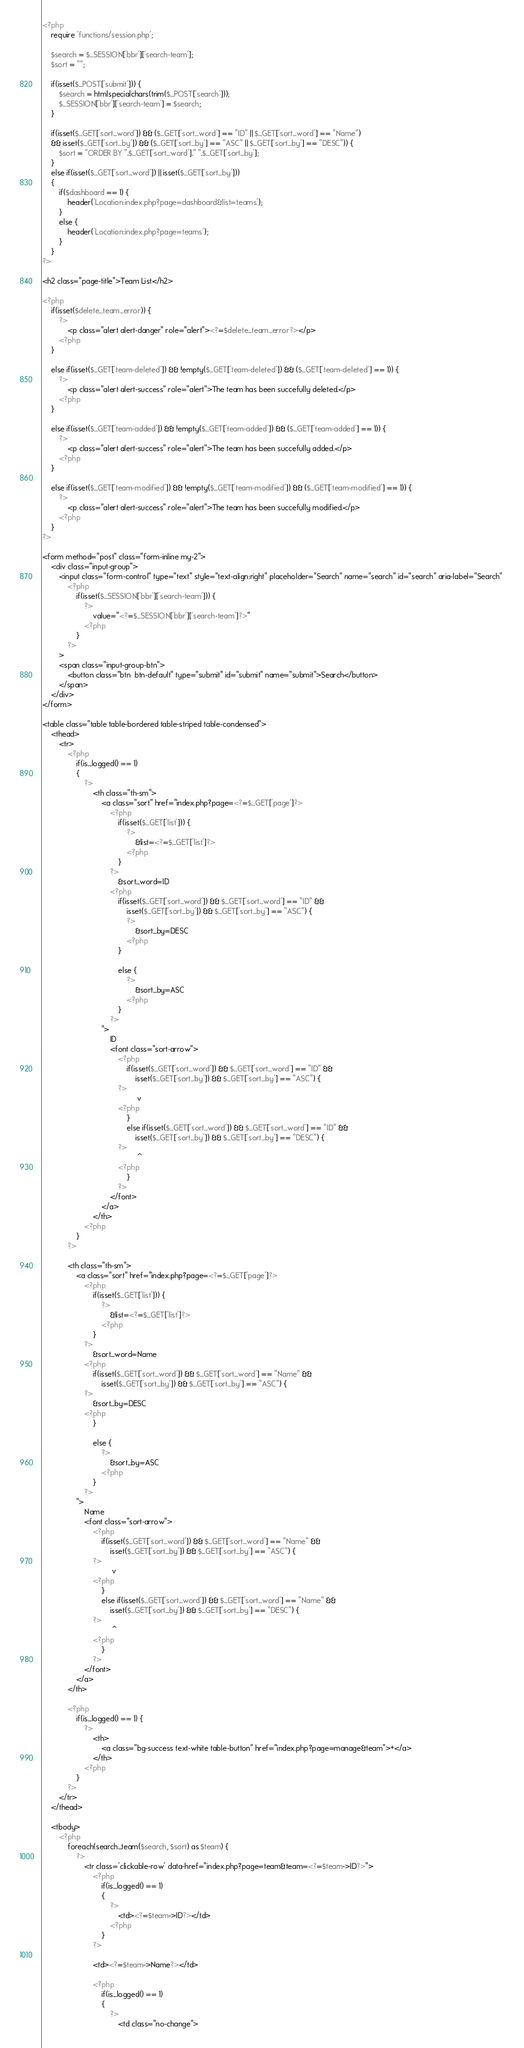Convert code to text. <code><loc_0><loc_0><loc_500><loc_500><_PHP_><?php
	require 'functions/session.php';

	$search = $_SESSION['bbr']['search-team'];
	$sort = "";
	
	if(isset($_POST['submit'])) {
		$search = htmlspecialchars(trim($_POST['search']));
		$_SESSION['bbr']['search-team'] = $search;
	}
	
	if(isset($_GET['sort_word']) && ($_GET['sort_word'] == "ID" || $_GET['sort_word'] == "Name")
	&& isset($_GET['sort_by']) && ($_GET['sort_by'] == "ASC" || $_GET['sort_by'] == "DESC")) {
		$sort = "ORDER BY ".$_GET['sort_word']." ".$_GET['sort_by'];
	}
	else if(isset($_GET['sort_word']) || isset($_GET['sort_by']))
	{
		if($dashboard == 1) {
			header('Location:index.php?page=dashboard&list=teams');
		}
		else {
			header('Location:index.php?page=teams');
		}
	}
?>

<h2 class="page-title">Team List</h2>
		
<?php
	if(isset($delete_team_error)) {
		?>
			<p class="alert alert-danger" role="alert"><?=$delete_team_error?></p>
		<?php
	}
	
	else if(isset($_GET['team-deleted']) && !empty($_GET['team-deleted']) && ($_GET['team-deleted'] == 1)) {
		?>
			<p class="alert alert-success" role="alert">The team has been succefully deleted.</p>
		<?php
	}
	
	else if(isset($_GET['team-added']) && !empty($_GET['team-added']) && ($_GET['team-added'] == 1)) {				
		?>
			<p class="alert alert-success" role="alert">The team has been succefully added.</p>
		<?php
	}
	
	else if(isset($_GET['team-modified']) && !empty($_GET['team-modified']) && ($_GET['team-modified'] == 1)) {				
		?>
			<p class="alert alert-success" role="alert">The team has been succefully modified.</p>
		<?php
	}
?>

<form method="post" class="form-inline my-2">
	<div class="input-group">
		<input class="form-control" type="text" style="text-align:right" placeholder="Search" name="search" id="search" aria-label="Search" 
			<?php
				if(isset($_SESSION['bbr']['search-team'])) {
					?>
						value="<?=$_SESSION['bbr']['search-team']?>"
					<?php
				}
			?>
		>    
		<span class="input-group-btn">
			<button class="btn  btn-default" type="submit" id="submit" name="submit">Search</button>
		</span>
	</div>
</form>

<table class="table table-bordered table-striped table-condensed">
	<thead>
		<tr>			
			<?php
				if(is_logged() == 1)
				{
					?>
						<th class="th-sm">
							<a class="sort" href="index.php?page=<?=$_GET['page']?>
								<?php
									if(isset($_GET['list'])) {
										?>
											&list=<?=$_GET['list']?>
										<?php
									}
								?>
									&sort_word=ID
								<?php
									if(isset($_GET['sort_word']) && $_GET['sort_word'] == "ID" &&
										isset($_GET['sort_by']) && $_GET['sort_by'] == "ASC") {
										?>
											&sort_by=DESC
										<?php
									}
									
									else {
										?>
											&sort_by=ASC
										<?php
									}
								?>
							">
								ID
								<font class="sort-arrow">
									<?php
										if(isset($_GET['sort_word']) && $_GET['sort_word'] == "ID" &&
											isset($_GET['sort_by']) && $_GET['sort_by'] == "ASC") {
									?>
											 v
									<?php
										}
										else if(isset($_GET['sort_word']) && $_GET['sort_word'] == "ID" &&
											isset($_GET['sort_by']) && $_GET['sort_by'] == "DESC") {
									?>
											 ^
									<?php
										}
									?>
								</font>
							</a>
						</th>
					<?php
				}
			?>
			
			<th class="th-sm">
				<a class="sort" href="index.php?page=<?=$_GET['page']?>
					<?php
						if(isset($_GET['list'])) {
							?>
								&list=<?=$_GET['list']?>
							<?php
						}
					?>
						&sort_word=Name
					<?php
						if(isset($_GET['sort_word']) && $_GET['sort_word'] == "Name" &&
							isset($_GET['sort_by']) && $_GET['sort_by'] == "ASC") {
					?>
						&sort_by=DESC
					<?php
						}
						
						else {
							?>
								&sort_by=ASC
							<?php
						}
					?>
				">
					Name
					<font class="sort-arrow">
						<?php
							if(isset($_GET['sort_word']) && $_GET['sort_word'] == "Name" &&
								isset($_GET['sort_by']) && $_GET['sort_by'] == "ASC") {
						?>
								 v
						<?php
							}
							else if(isset($_GET['sort_word']) && $_GET['sort_word'] == "Name" &&
								isset($_GET['sort_by']) && $_GET['sort_by'] == "DESC") {
						?>
								 ^
						<?php
							}
						?>
					</font>
				</a>
			</th>
			
			<?php
				if(is_logged() == 1) {
					?>
						<th>
							<a class="bg-success text-white table-button" href="index.php?page=manage&team">+</a>
						</th>
					<?php
				}
			?>
		</tr>
	</thead>
	
	<tbody>
		<?php
			foreach(search_team($search, $sort) as $team) {		
				?>		
					<tr class='clickable-row' data-href="index.php?page=team&team=<?=$team->ID?>">
						<?php
							if(is_logged() == 1)
							{
								?>
									<td><?=$team->ID?></td>
								<?php
							}
						?>
						
						<td><?=$team->Name?></td>
						
						<?php
							if(is_logged() == 1)
							{
								?>
									<td class="no-change"></code> 